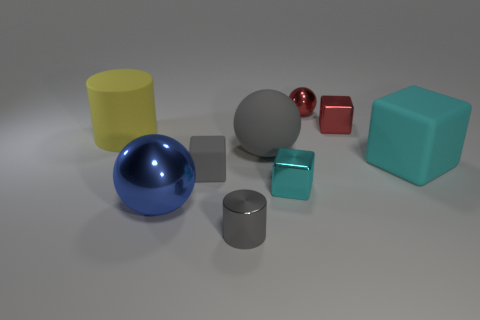What number of other objects are there of the same color as the small shiny cylinder? There are two other objects that share the same shiny silver color as the small cylinder: a sphere and a cube. 